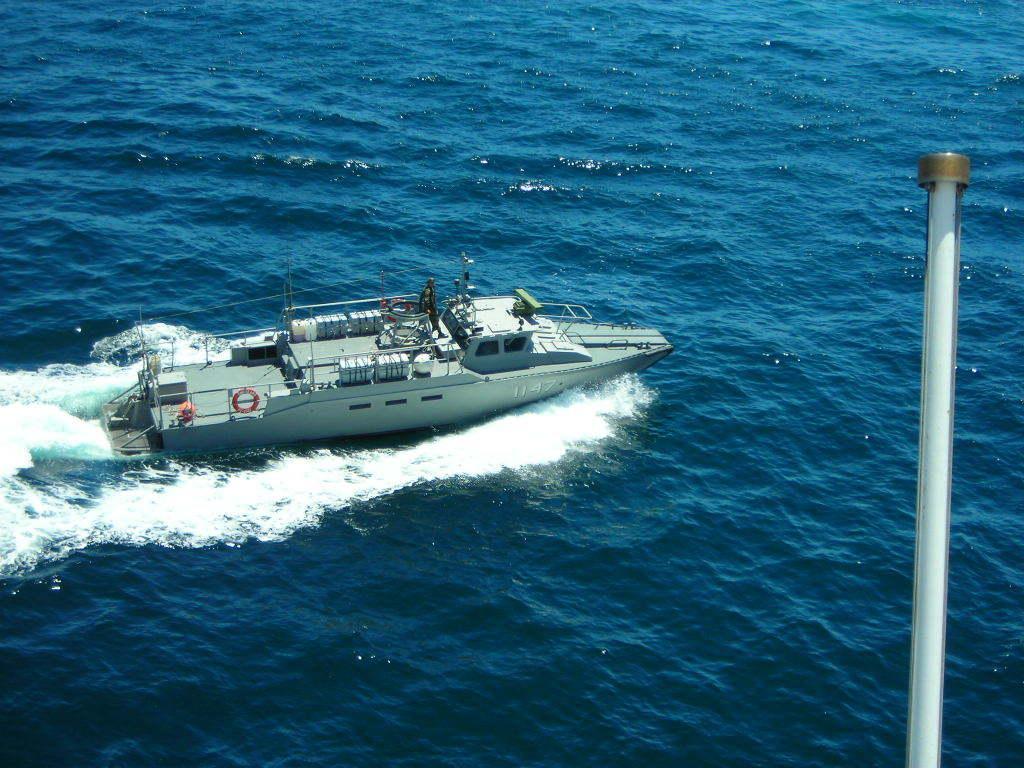Please provide a concise description of this image. This picture is clicked outside the city. On the right there is a pole. In the center there is a boat running in the water body. On the left corner we can see the ripples in the water body. 